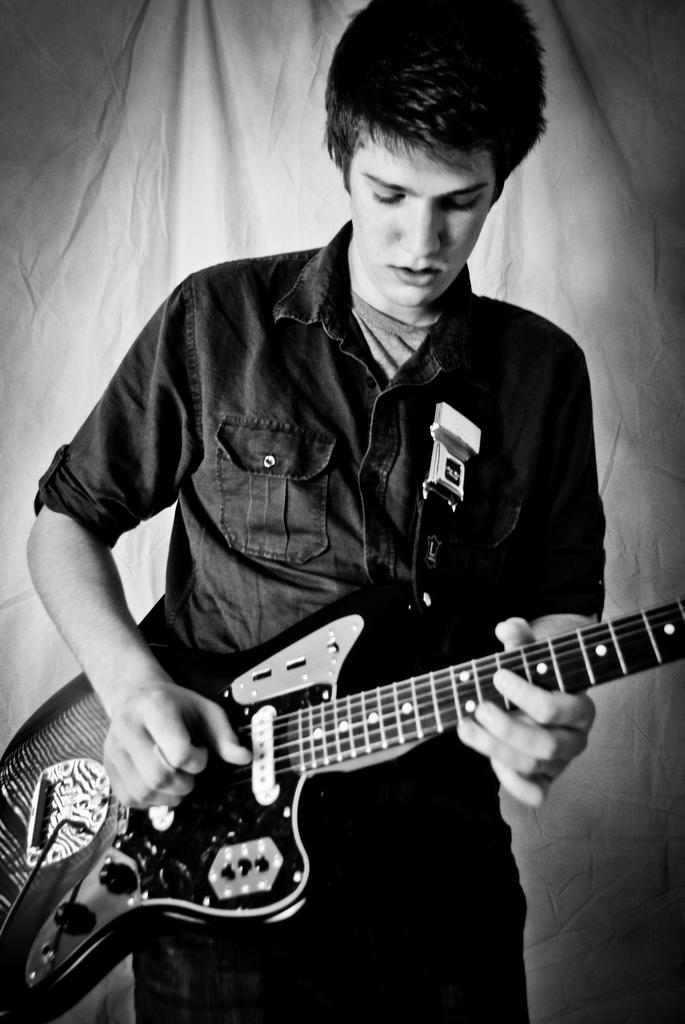Who is present in the image? There is a man in the image. What is the man doing in the image? The man is standing in the image. What object is the man holding in the image? The man is holding a guitar in the image. What type of vegetable is the man eating in the image? There is no vegetable present in the image, and the man is not eating anything. 